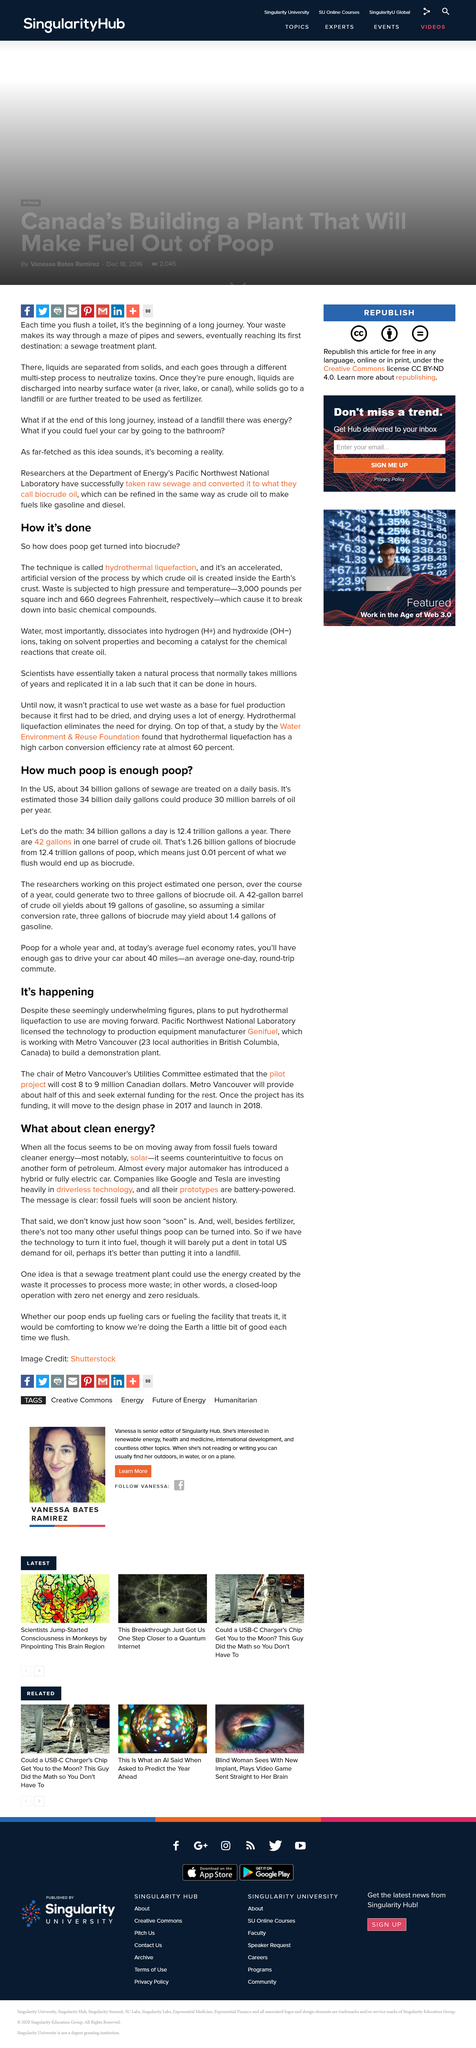Indicate a few pertinent items in this graphic. According to research, an individual can produce two to three gallons of biocrude oil over the course of a year through a project. The temperature to which waste is subjected is 660 degrees Fahrenheit. Water dissociates into hydrogen and hydroxide ions when it comes into contact with certain substances. I have determined that the technique that transforms feces into biocrude is known as hydrothermal liquefaction. In the United States, approximately 34 billion gallons of sewage are treated on a daily basis. 